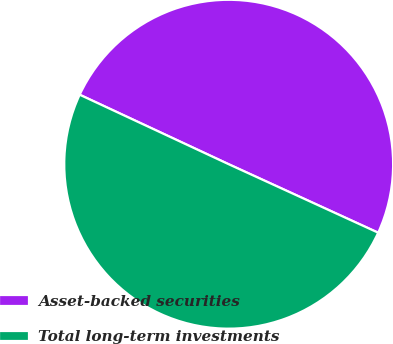Convert chart. <chart><loc_0><loc_0><loc_500><loc_500><pie_chart><fcel>Asset-backed securities<fcel>Total long-term investments<nl><fcel>49.89%<fcel>50.11%<nl></chart> 